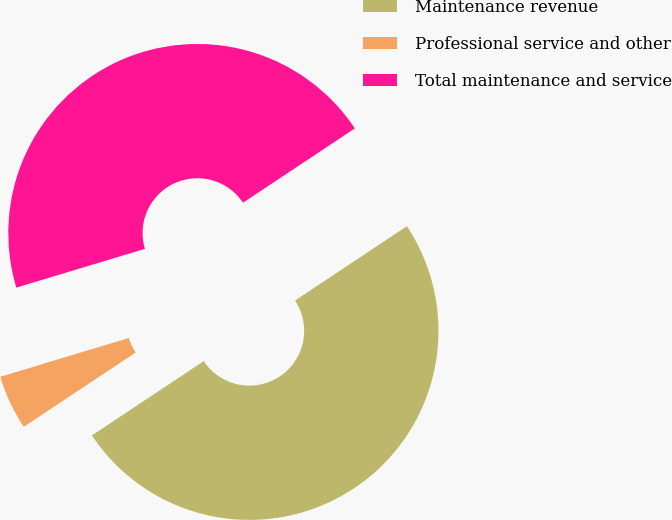<chart> <loc_0><loc_0><loc_500><loc_500><pie_chart><fcel>Maintenance revenue<fcel>Professional service and other<fcel>Total maintenance and service<nl><fcel>50.0%<fcel>4.67%<fcel>45.33%<nl></chart> 